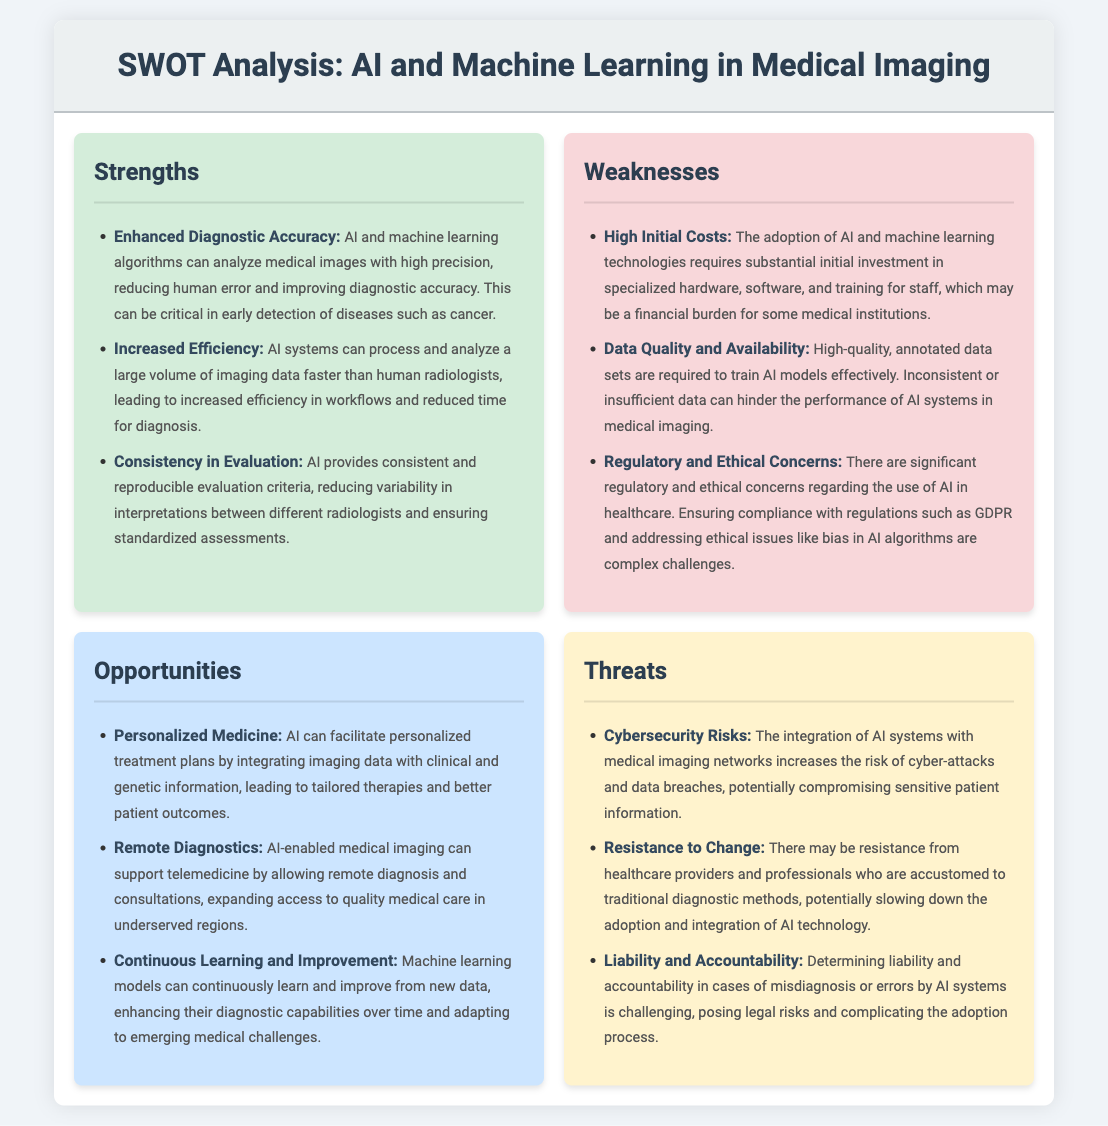What is one strength of AI in medical imaging? The strengths section lists several advantages, one of which is enhanced diagnostic accuracy.
Answer: Enhanced Diagnostic Accuracy What is a weakness related to the costs of adopting AI? The weaknesses section mentions that the adoption requires substantial initial investment, indicating high initial costs.
Answer: High Initial Costs What opportunity does AI provide for improving patient care? The opportunities section highlights personalized treatment plans as a benefit of integrating AI with imaging data.
Answer: Personalized Medicine What is a significant threat associated with integrating AI in medical imaging? The threats section discusses various risks, including cybersecurity risks as one significant concern.
Answer: Cybersecurity Risks How many strengths are listed in the document? The strengths section contains three distinct points related to AI's advantages in medical imaging.
Answer: Three What aspect of AI can enhance its performance over time, as mentioned in the opportunities? The document states that machine learning models can continuously learn and improve, contributing to better performance.
Answer: Continuous Learning and Improvement What regulatory concern is mentioned in the weaknesses? The weaknesses section lists regulatory and ethical concerns regarding the implementation of AI in healthcare.
Answer: Regulatory and Ethical Concerns Which threat may hinder the adoption of AI technologies among healthcare professionals? The threats section describes resistance to change from healthcare providers as a barrier to adopting AI.
Answer: Resistance to Change What term is used to describe AI's capability to offer remote diagnostics? The opportunities section refers to remote diagnostics as a benefit of AI-enabled medical imaging.
Answer: Remote Diagnostics 